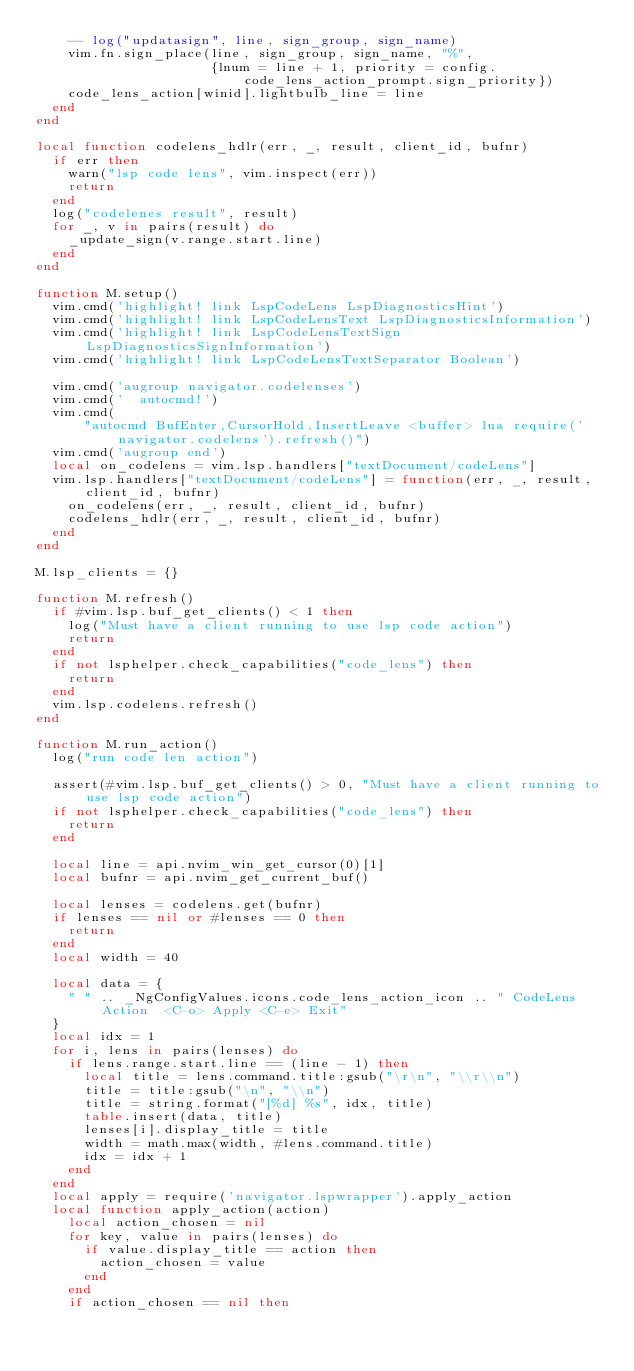<code> <loc_0><loc_0><loc_500><loc_500><_Lua_>    -- log("updatasign", line, sign_group, sign_name)
    vim.fn.sign_place(line, sign_group, sign_name, "%",
                      {lnum = line + 1, priority = config.code_lens_action_prompt.sign_priority})
    code_lens_action[winid].lightbulb_line = line
  end
end

local function codelens_hdlr(err, _, result, client_id, bufnr)
  if err then
    warn("lsp code lens", vim.inspect(err))
    return
  end
  log("codelenes result", result)
  for _, v in pairs(result) do
    _update_sign(v.range.start.line)
  end
end

function M.setup()
  vim.cmd('highlight! link LspCodeLens LspDiagnosticsHint')
  vim.cmd('highlight! link LspCodeLensText LspDiagnosticsInformation')
  vim.cmd('highlight! link LspCodeLensTextSign LspDiagnosticsSignInformation')
  vim.cmd('highlight! link LspCodeLensTextSeparator Boolean')

  vim.cmd('augroup navigator.codelenses')
  vim.cmd('  autocmd!')
  vim.cmd(
      "autocmd BufEnter,CursorHold,InsertLeave <buffer> lua require('navigator.codelens').refresh()")
  vim.cmd('augroup end')
  local on_codelens = vim.lsp.handlers["textDocument/codeLens"]
  vim.lsp.handlers["textDocument/codeLens"] = function(err, _, result, client_id, bufnr)
    on_codelens(err, _, result, client_id, bufnr)
    codelens_hdlr(err, _, result, client_id, bufnr)
  end
end

M.lsp_clients = {}

function M.refresh()
  if #vim.lsp.buf_get_clients() < 1 then
    log("Must have a client running to use lsp code action")
    return
  end
  if not lsphelper.check_capabilities("code_lens") then
    return
  end
  vim.lsp.codelens.refresh()
end

function M.run_action()
  log("run code len action")

  assert(#vim.lsp.buf_get_clients() > 0, "Must have a client running to use lsp code action")
  if not lsphelper.check_capabilities("code_lens") then
    return
  end

  local line = api.nvim_win_get_cursor(0)[1]
  local bufnr = api.nvim_get_current_buf()

  local lenses = codelens.get(bufnr)
  if lenses == nil or #lenses == 0 then
    return
  end
  local width = 40

  local data = {
    " " .. _NgConfigValues.icons.code_lens_action_icon .. " CodeLens Action  <C-o> Apply <C-e> Exit"
  }
  local idx = 1
  for i, lens in pairs(lenses) do
    if lens.range.start.line == (line - 1) then
      local title = lens.command.title:gsub("\r\n", "\\r\\n")
      title = title:gsub("\n", "\\n")
      title = string.format("[%d] %s", idx, title)
      table.insert(data, title)
      lenses[i].display_title = title
      width = math.max(width, #lens.command.title)
      idx = idx + 1
    end
  end
  local apply = require('navigator.lspwrapper').apply_action
  local function apply_action(action)
    local action_chosen = nil
    for key, value in pairs(lenses) do
      if value.display_title == action then
        action_chosen = value
      end
    end
    if action_chosen == nil then</code> 